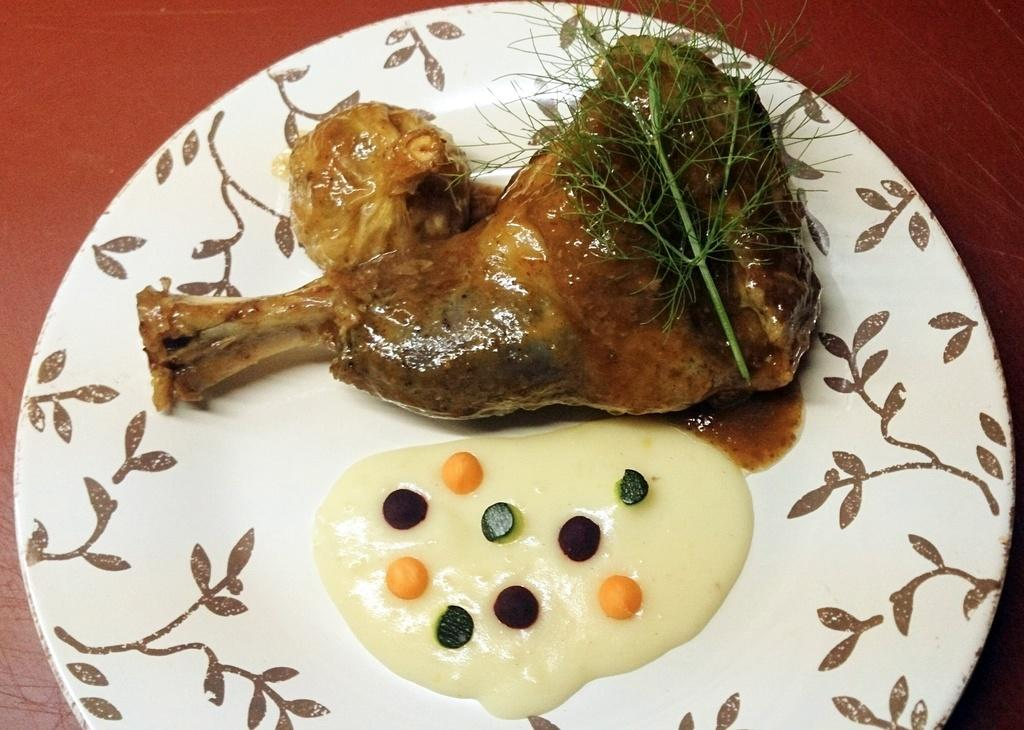What type of furniture is present in the image? There is a table in the image. What can be found on top of the table? There are food items on the table. Can you describe any other objects or elements in the image? Yes, there is a leaf in the image. How many ducks are sitting on the table in the image? There are no ducks present on the table in the image. What type of leg is visible in the image? There is no leg visible in the image. 